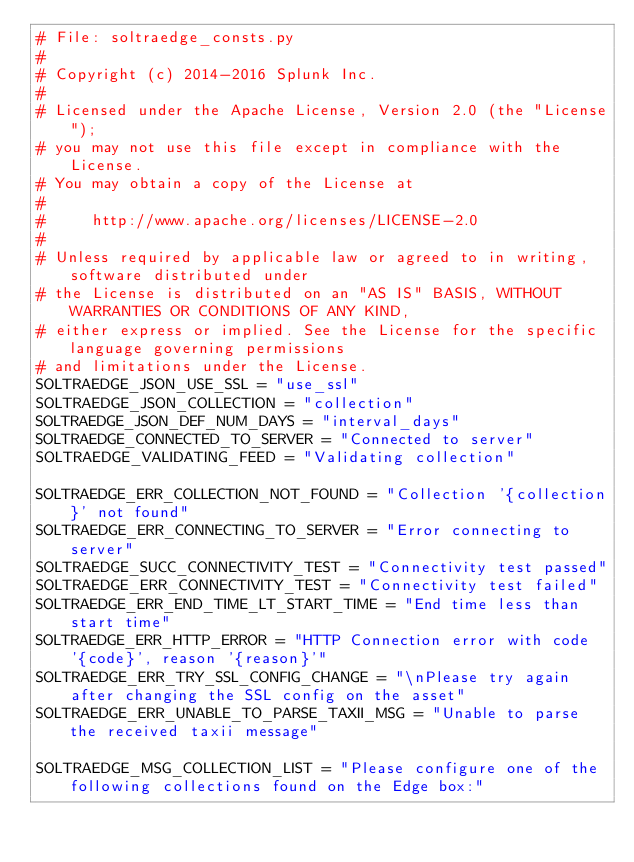<code> <loc_0><loc_0><loc_500><loc_500><_Python_># File: soltraedge_consts.py
#
# Copyright (c) 2014-2016 Splunk Inc.
#
# Licensed under the Apache License, Version 2.0 (the "License");
# you may not use this file except in compliance with the License.
# You may obtain a copy of the License at
#
#     http://www.apache.org/licenses/LICENSE-2.0
#
# Unless required by applicable law or agreed to in writing, software distributed under
# the License is distributed on an "AS IS" BASIS, WITHOUT WARRANTIES OR CONDITIONS OF ANY KIND,
# either express or implied. See the License for the specific language governing permissions
# and limitations under the License.
SOLTRAEDGE_JSON_USE_SSL = "use_ssl"
SOLTRAEDGE_JSON_COLLECTION = "collection"
SOLTRAEDGE_JSON_DEF_NUM_DAYS = "interval_days"
SOLTRAEDGE_CONNECTED_TO_SERVER = "Connected to server"
SOLTRAEDGE_VALIDATING_FEED = "Validating collection"

SOLTRAEDGE_ERR_COLLECTION_NOT_FOUND = "Collection '{collection}' not found"
SOLTRAEDGE_ERR_CONNECTING_TO_SERVER = "Error connecting to server"
SOLTRAEDGE_SUCC_CONNECTIVITY_TEST = "Connectivity test passed"
SOLTRAEDGE_ERR_CONNECTIVITY_TEST = "Connectivity test failed"
SOLTRAEDGE_ERR_END_TIME_LT_START_TIME = "End time less than start time"
SOLTRAEDGE_ERR_HTTP_ERROR = "HTTP Connection error with code '{code}', reason '{reason}'"
SOLTRAEDGE_ERR_TRY_SSL_CONFIG_CHANGE = "\nPlease try again after changing the SSL config on the asset"
SOLTRAEDGE_ERR_UNABLE_TO_PARSE_TAXII_MSG = "Unable to parse the received taxii message"

SOLTRAEDGE_MSG_COLLECTION_LIST = "Please configure one of the following collections found on the Edge box:"</code> 